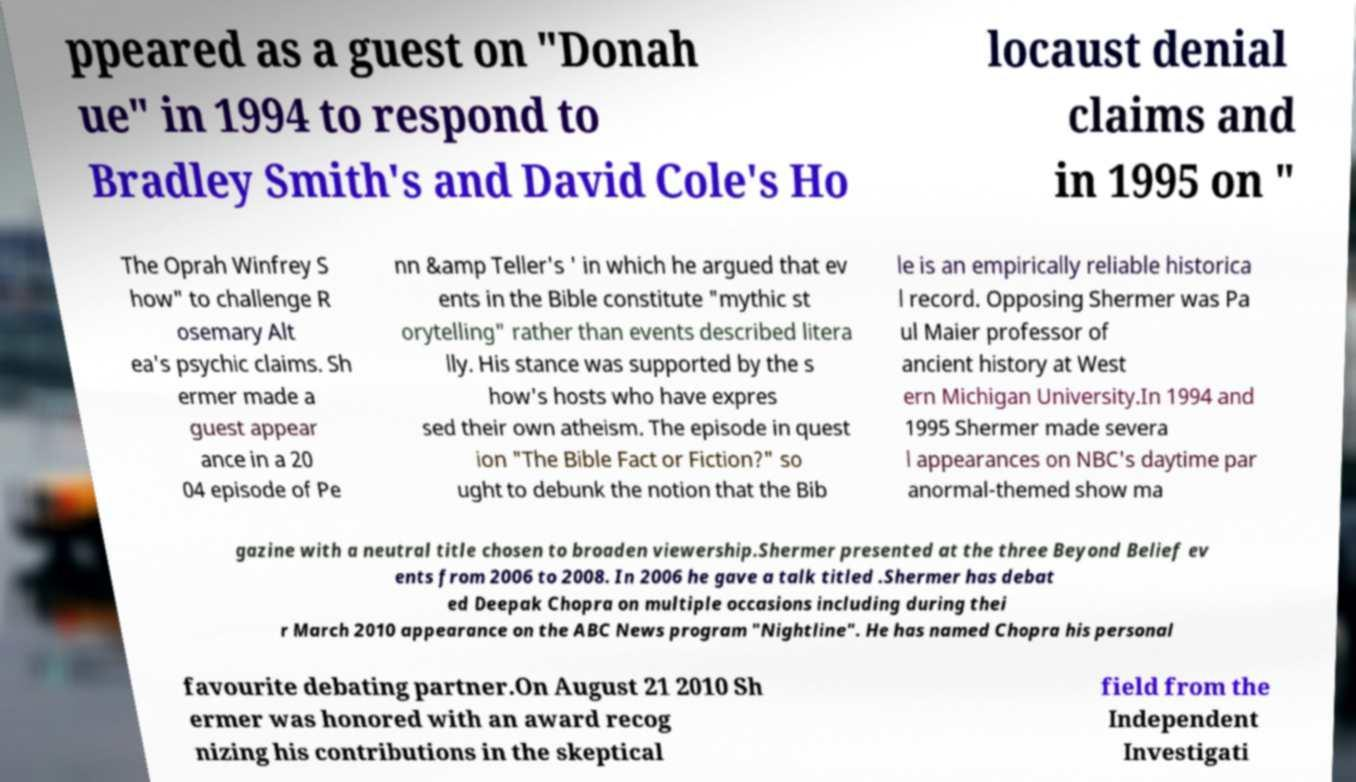Please read and relay the text visible in this image. What does it say? ppeared as a guest on "Donah ue" in 1994 to respond to Bradley Smith's and David Cole's Ho locaust denial claims and in 1995 on " The Oprah Winfrey S how" to challenge R osemary Alt ea's psychic claims. Sh ermer made a guest appear ance in a 20 04 episode of Pe nn &amp Teller's ' in which he argued that ev ents in the Bible constitute "mythic st orytelling" rather than events described litera lly. His stance was supported by the s how's hosts who have expres sed their own atheism. The episode in quest ion "The Bible Fact or Fiction?" so ught to debunk the notion that the Bib le is an empirically reliable historica l record. Opposing Shermer was Pa ul Maier professor of ancient history at West ern Michigan University.In 1994 and 1995 Shermer made severa l appearances on NBC's daytime par anormal-themed show ma gazine with a neutral title chosen to broaden viewership.Shermer presented at the three Beyond Belief ev ents from 2006 to 2008. In 2006 he gave a talk titled .Shermer has debat ed Deepak Chopra on multiple occasions including during thei r March 2010 appearance on the ABC News program "Nightline". He has named Chopra his personal favourite debating partner.On August 21 2010 Sh ermer was honored with an award recog nizing his contributions in the skeptical field from the Independent Investigati 